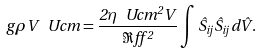<formula> <loc_0><loc_0><loc_500><loc_500>g \rho V \ U c m = \frac { 2 \eta \ U c m ^ { 2 } V } { \Re f f ^ { 2 } } \int \hat { S } _ { i j } \hat { S } _ { i j } d \hat { V } .</formula> 